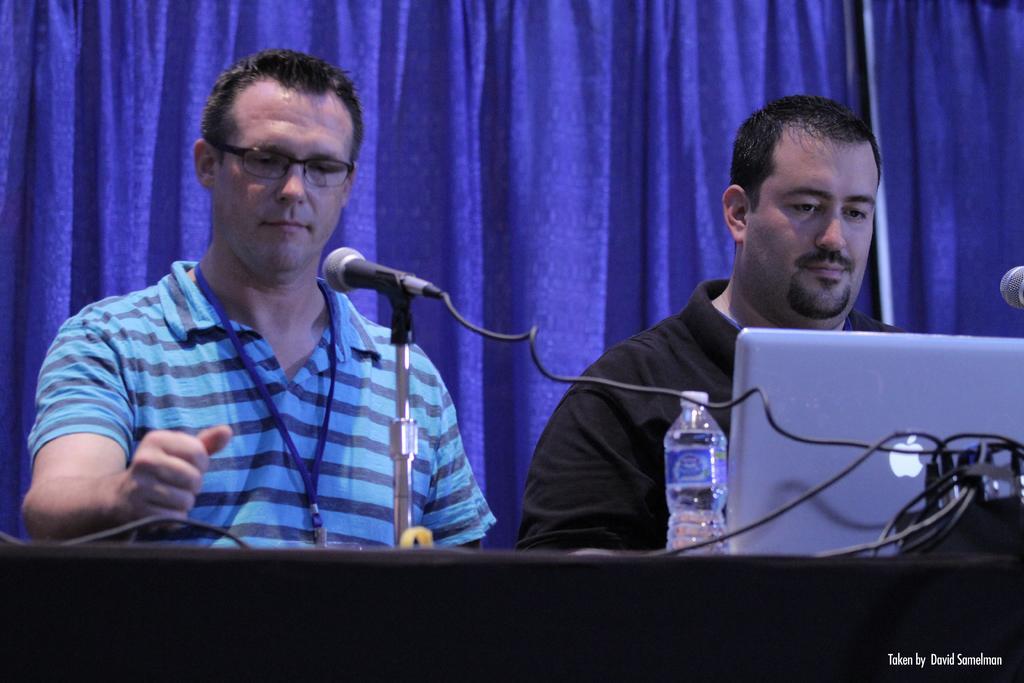Could you give a brief overview of what you see in this image? In this image we can see this person wearing blue T-shirt, identity card and glasses and this person wearing black T-shirt are there in front of the table. Here we can see mics with stand, bottles and laptop placed on the table. In the background, we can see blue curtains. 